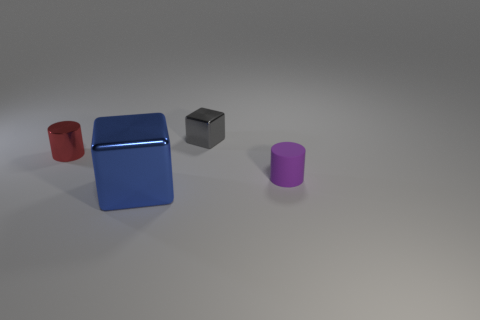The tiny thing left of the metal block in front of the small cylinder left of the tiny purple cylinder is what color?
Your response must be concise. Red. What number of other objects are the same material as the tiny block?
Make the answer very short. 2. Do the thing to the right of the gray thing and the large shiny thing have the same shape?
Provide a short and direct response. No. What number of large things are red cylinders or brown rubber cylinders?
Keep it short and to the point. 0. Is the number of small cylinders that are to the right of the purple cylinder the same as the number of tiny red cylinders behind the tiny red metal cylinder?
Provide a short and direct response. Yes. What number of other objects are the same color as the large shiny object?
Offer a very short reply. 0. There is a small matte cylinder; does it have the same color as the tiny cylinder that is left of the large blue metal block?
Make the answer very short. No. How many red things are big metal objects or small matte objects?
Provide a succinct answer. 0. Are there an equal number of cylinders that are to the right of the rubber object and tiny brown metallic cylinders?
Your answer should be compact. Yes. Are there any other things that have the same size as the purple matte cylinder?
Make the answer very short. Yes. 